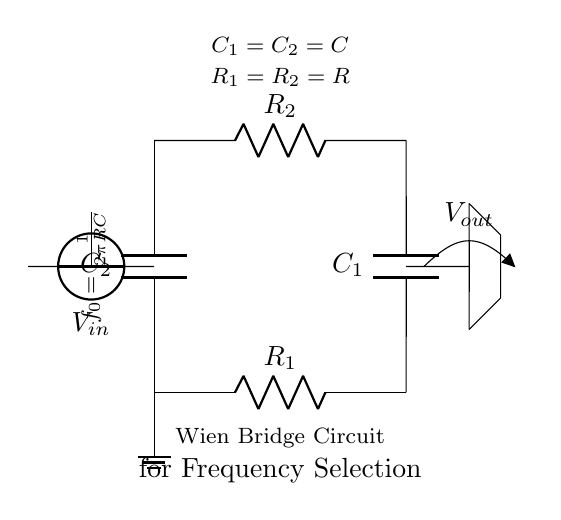What is the input voltage named in this circuit? The input voltage is labeled as V_in in the circuit diagram, indicating the voltage source connected to the input of the Wien bridge circuit.
Answer: V_in What types of components are present in this Wien bridge circuit? The circuit includes resistors (R_1 and R_2) and capacitors (C_1 and C_2), which are essential components for frequency selection in signal processing applications.
Answer: Resistors and capacitors How many resistors are used in the Wien bridge circuit? The diagram shows two resistors labeled R_1 and R_2 connected in a specific configuration, which indicates that two resistors are utilized in this circuit.
Answer: Two What is the relationship between R_1 and R_2? The circuit specifies that R_1 and R_2 are equal, as denoted in the indicated label within the diagram, which relates to the balancing of the bridge for desired frequency selection.
Answer: R_1 = R_2 What is the expression used to determine the frequency f_0? The formula shown in the circuit is f_0 equals one divided by two pi times R multiplied by C, representing the fundamental frequency for the oscillation in the Wien bridge circuit.
Answer: f_0 = 1/(2πRC) What would happen if R_1 and R_2 were not equal? If R_1 and R_2 are not equal, the balance of the bridge would be disrupted, leading to incorrect frequency selection and potentially causing distortion in the output signal.
Answer: Distorted output What is the value of C_1 in relation to C_2? The circuit diagram indicates that C_1 is equal to C_2, which is important for maintaining the frequency response of the circuit consistent.
Answer: C_1 = C_2 